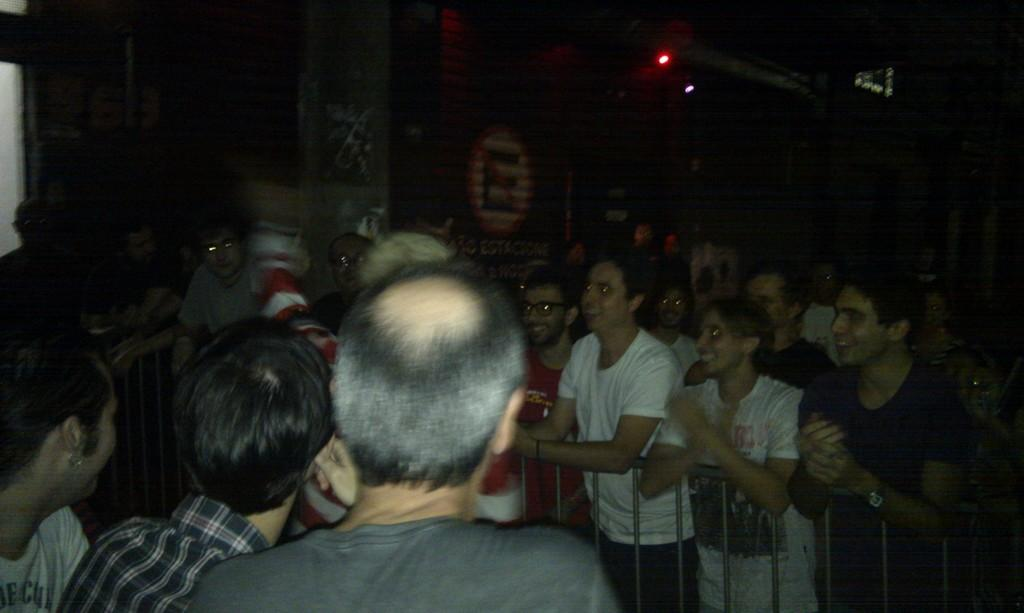How many people are in the image? There is a group of people in the image. What are some people doing in relation to the fence? Some people are standing behind a fence. What can be seen in the background of the image? There are lights visible in the background of the image. How would you describe the overall lighting in the image? The background of the image is dark. What type of soup is being served to the cat in the image? There is no cat or soup present in the image. What angle is the image taken from? The angle from which the image is taken is not mentioned in the provided facts, so it cannot be determined. 